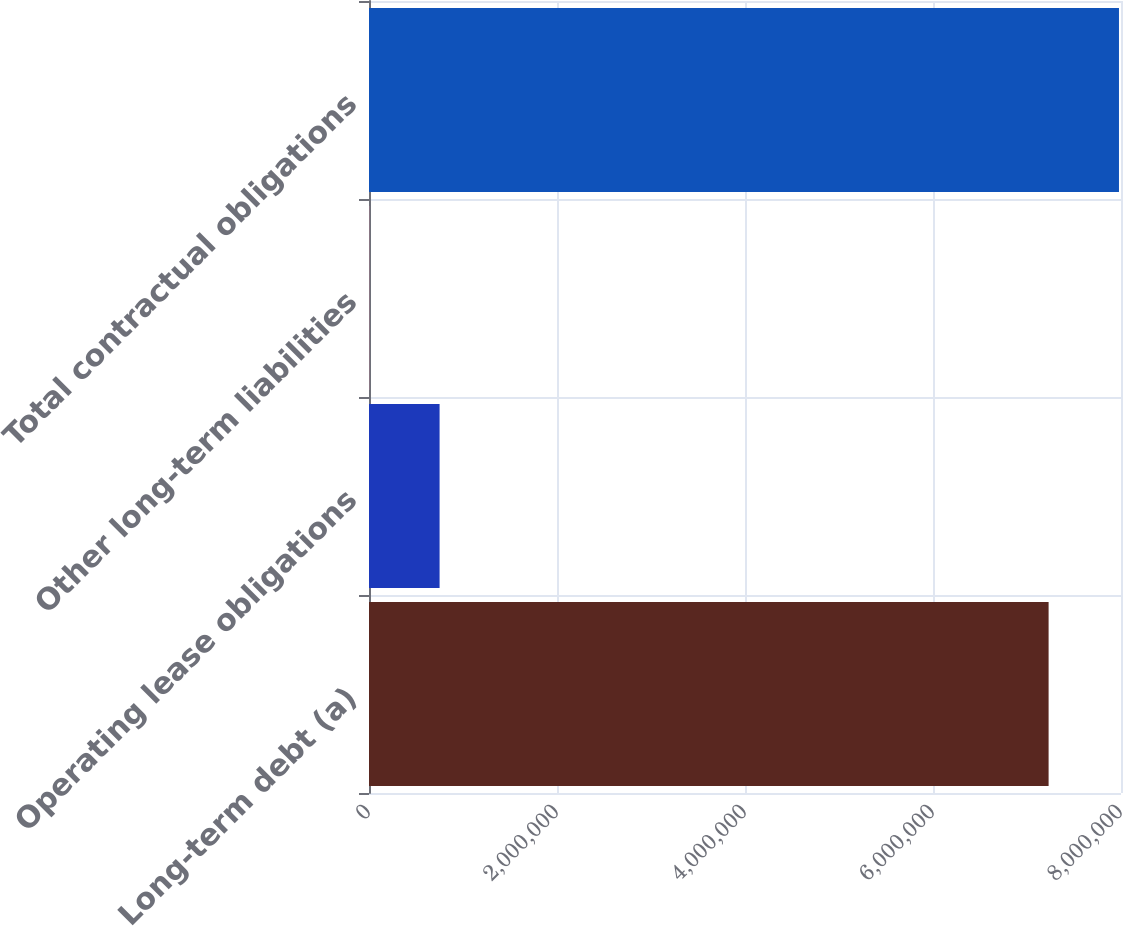<chart> <loc_0><loc_0><loc_500><loc_500><bar_chart><fcel>Long-term debt (a)<fcel>Operating lease obligations<fcel>Other long-term liabilities<fcel>Total contractual obligations<nl><fcel>7.22984e+06<fcel>750930<fcel>2337<fcel>7.97843e+06<nl></chart> 